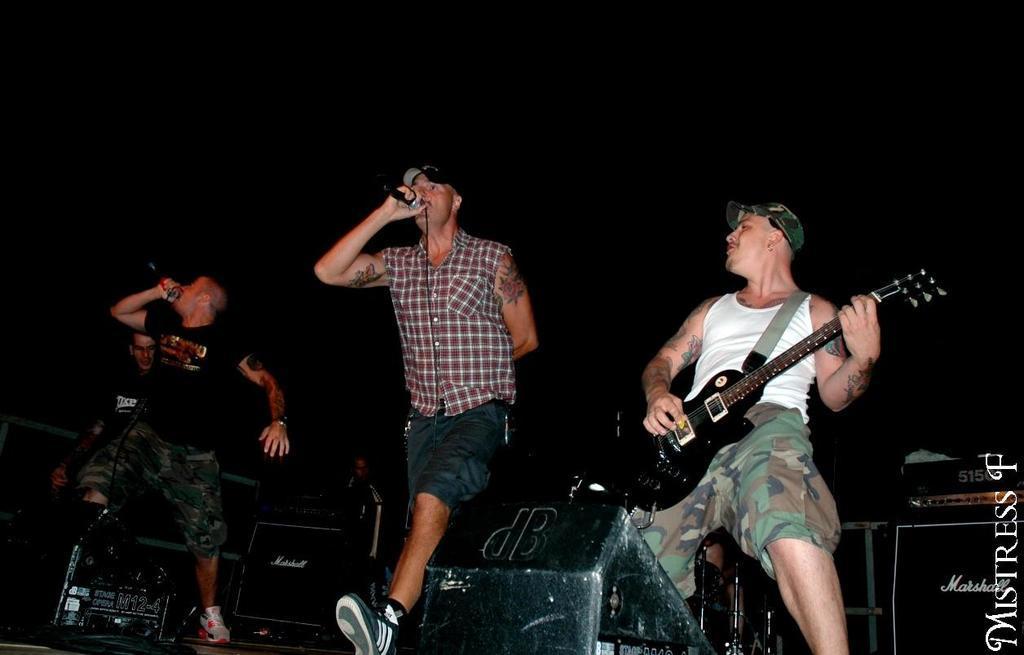How would you summarize this image in a sentence or two? In this image we can see four men on the stage. One man is wearing white color t-shirt with shorts and playing guitar. The other one is wearing shirt with shorts and holding mic. The third one is wearing black color t-shirt and holding mic and forth person is playing some musical instrument. Bottom of the image black color thing is present. 